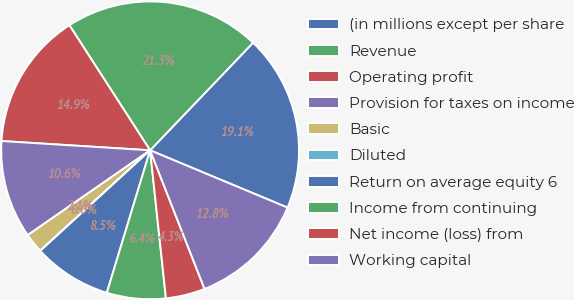Convert chart. <chart><loc_0><loc_0><loc_500><loc_500><pie_chart><fcel>(in millions except per share<fcel>Revenue<fcel>Operating profit<fcel>Provision for taxes on income<fcel>Basic<fcel>Diluted<fcel>Return on average equity 6<fcel>Income from continuing<fcel>Net income (loss) from<fcel>Working capital<nl><fcel>19.14%<fcel>21.27%<fcel>14.89%<fcel>10.64%<fcel>2.14%<fcel>0.01%<fcel>8.51%<fcel>6.39%<fcel>4.26%<fcel>12.76%<nl></chart> 